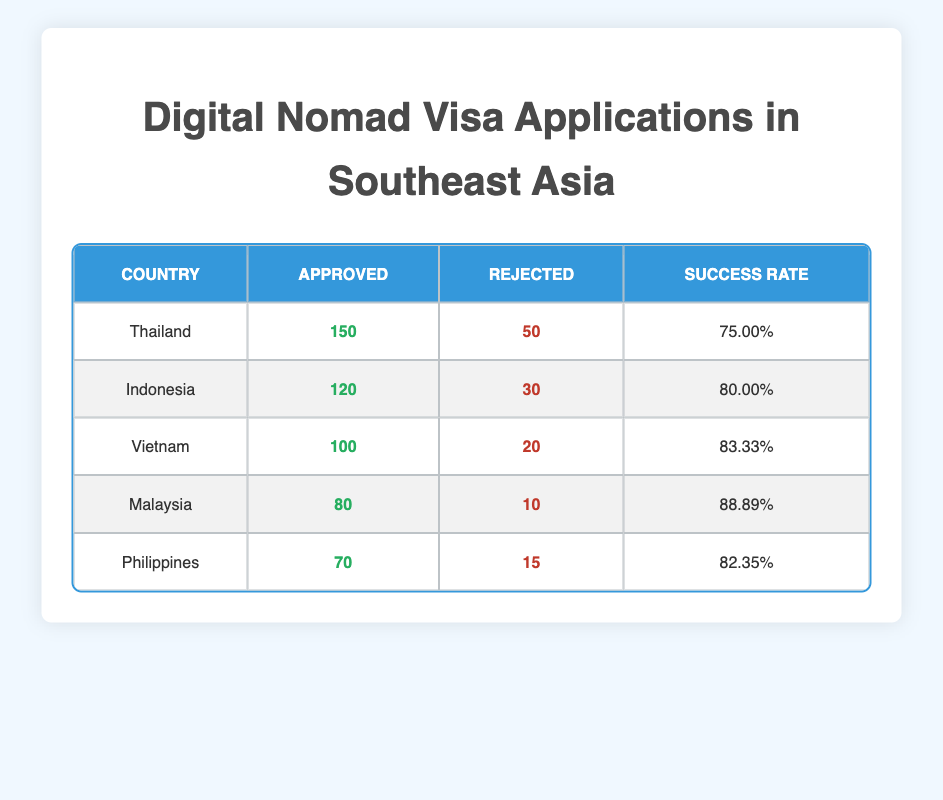What is the success rate for visa applications in Thailand? The success rate for Thailand is already provided in the table. It shows that there were 150 approved applications out of a total of 200 (150 approved + 50 rejected). Therefore, the success rate is (150/200) * 100 = 75.00%.
Answer: 75.00% Which country had the highest number of approved visa applications? Referring to the table, Thailand has 150 approved applications, which is higher than any other country listed.
Answer: Thailand What is the total number of visa applications (approved + rejected) for Indonesia? To find the total for Indonesia, we sum the approved (120) and rejected applications (30) as provided in the table. Therefore, 120 + 30 = 150 total applications.
Answer: 150 Is the rejection rate higher in the Philippines than in Malaysia? The rejection rate can be calculated by dividing the number of rejected applications by the total applications. For the Philippines: 15 rejected out of 85 total (70 approved + 15 rejected) gives a rejection rate of 17.65%. For Malaysia: 10 rejected out of 90 total (80 approved + 10 rejected) gives a rejection rate of 11.11%. Since 17.65% is greater than 11.11%, the rejection rate is indeed higher in the Philippines.
Answer: Yes What is the average success rate of all the countries listed? The success rates from the table are: 75.00%, 80.00%, 83.33%, 88.89%, and 82.35%. First, we sum these percentages: 75.00 + 80.00 + 83.33 + 88.89 + 82.35 = 409.57. Then, we divide by the number of countries (5): 409.57 / 5 = 81.91%.
Answer: 81.91% 